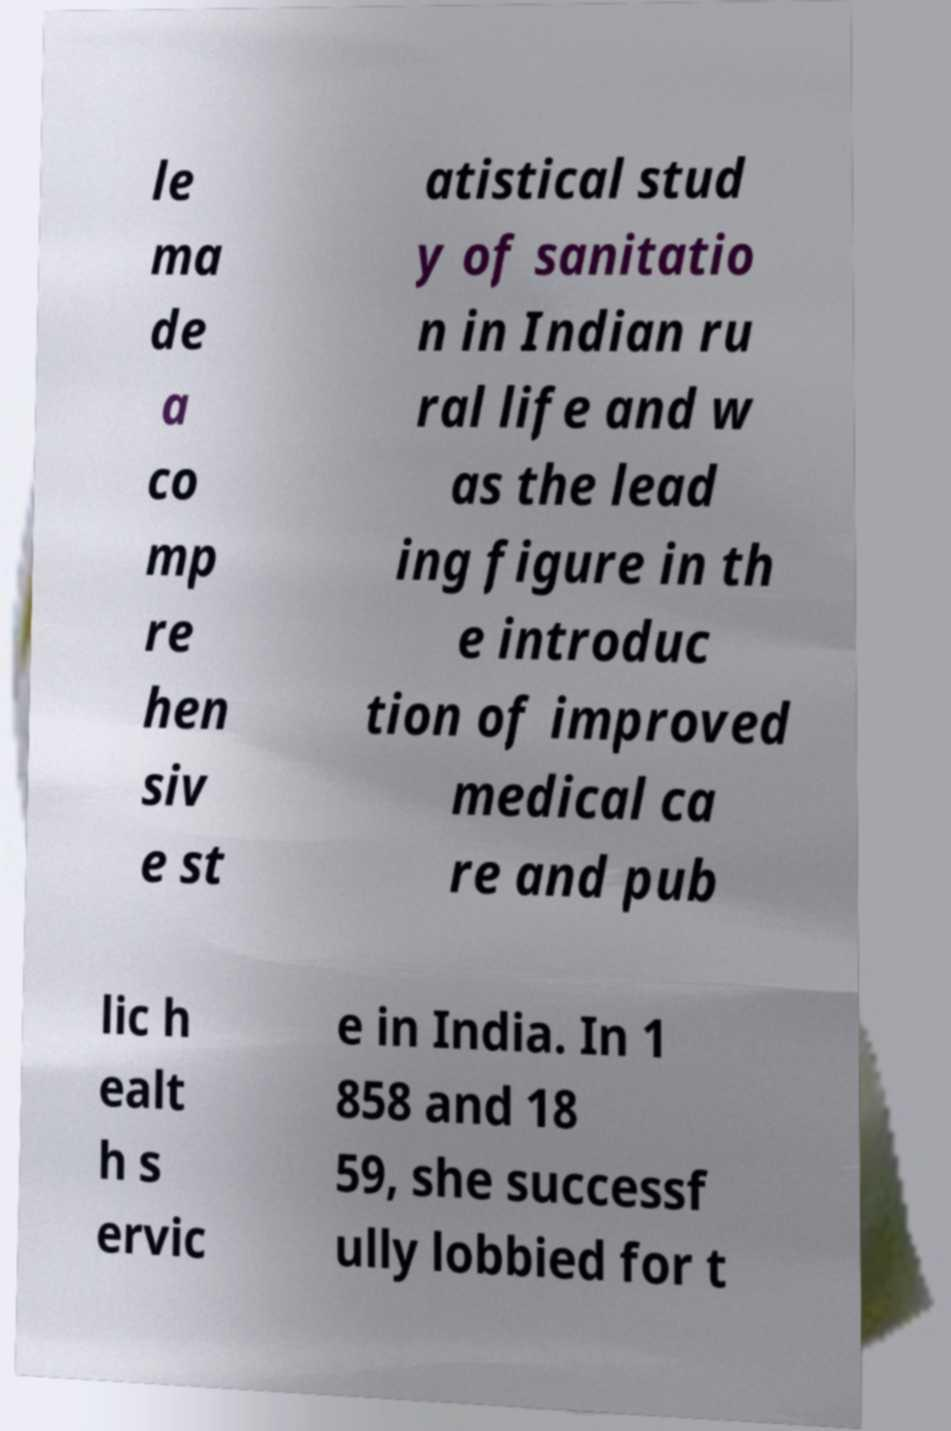Please identify and transcribe the text found in this image. le ma de a co mp re hen siv e st atistical stud y of sanitatio n in Indian ru ral life and w as the lead ing figure in th e introduc tion of improved medical ca re and pub lic h ealt h s ervic e in India. In 1 858 and 18 59, she successf ully lobbied for t 